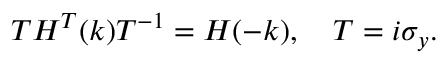<formula> <loc_0><loc_0><loc_500><loc_500>\begin{array} { r } { T H ^ { T } ( k ) T ^ { - 1 } = H ( - k ) , \quad T = i \sigma _ { y } . } \end{array}</formula> 